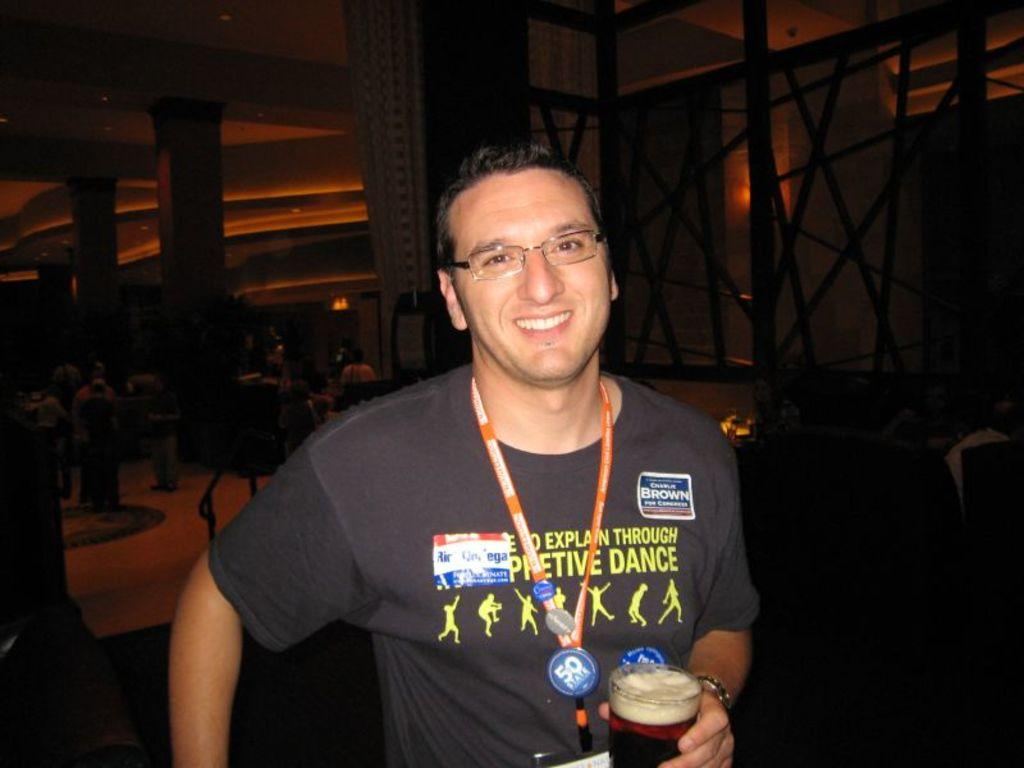What is the man in the image doing? The man is standing and smiling in the image. Can you describe the man's attire? The man is wearing a tag in the image. What is the man holding in his hand? The man is holding a glass in his hand. What can be seen in the background of the image? There is a group of people in the background of the image, with some standing and some sitting. What type of loaf is the man holding in the image? There is no loaf present in the image; the man is holding a glass. Can you describe the shade of the kettle in the image? There is no kettle present in the image. 